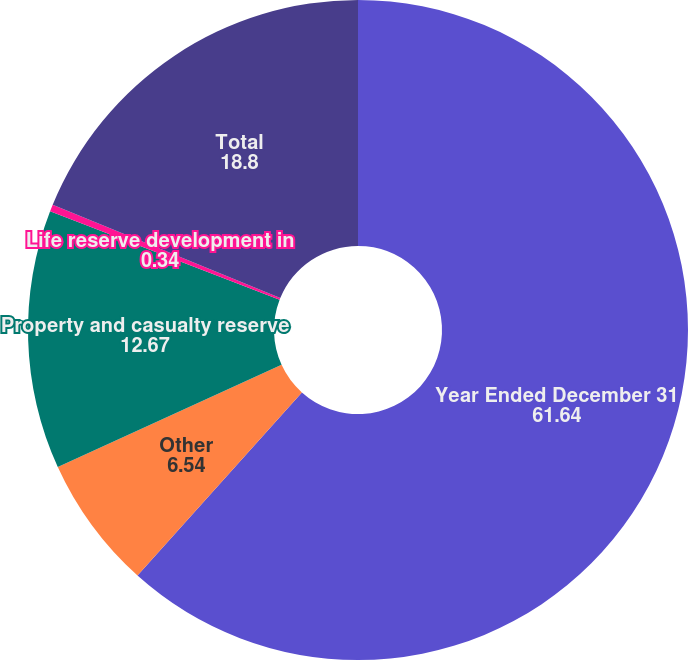Convert chart to OTSL. <chart><loc_0><loc_0><loc_500><loc_500><pie_chart><fcel>Year Ended December 31<fcel>Other<fcel>Property and casualty reserve<fcel>Life reserve development in<fcel>Total<nl><fcel>61.64%<fcel>6.54%<fcel>12.67%<fcel>0.34%<fcel>18.8%<nl></chart> 